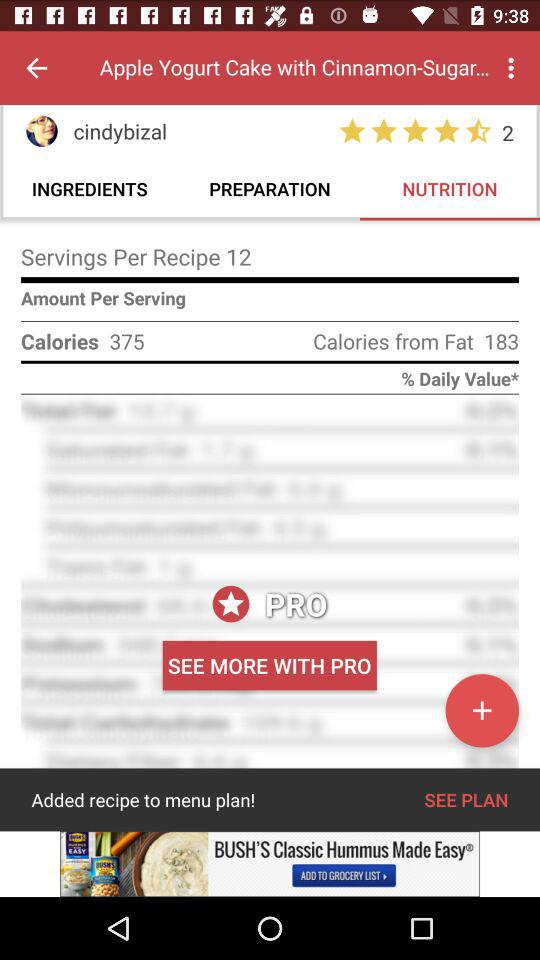How many calories are in this recipe per serving?
Answer the question using a single word or phrase. 375 